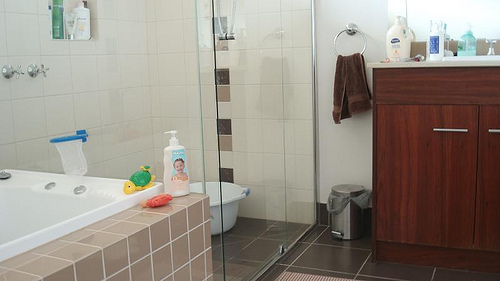Is there anything interesting or unique you can spot in this bathroom? An interesting aspect of this bathroom is the presence of a cute, colorful turtle toy on the bathtub's edge and how neatly everything is arranged. 